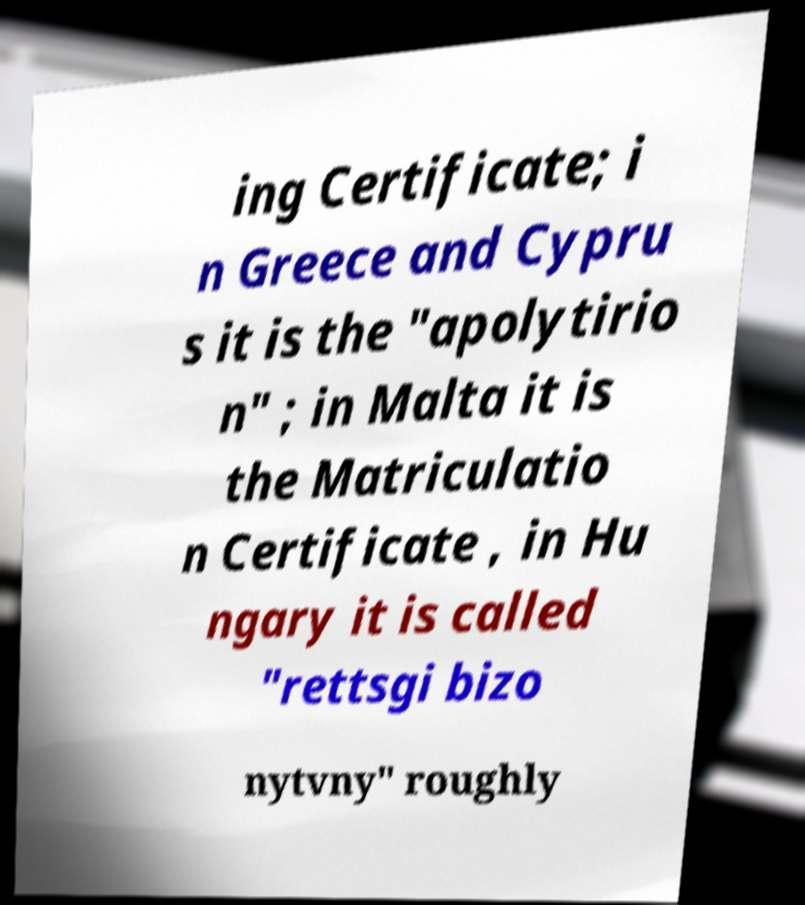Can you accurately transcribe the text from the provided image for me? ing Certificate; i n Greece and Cypru s it is the "apolytirio n" ; in Malta it is the Matriculatio n Certificate , in Hu ngary it is called "rettsgi bizo nytvny" roughly 